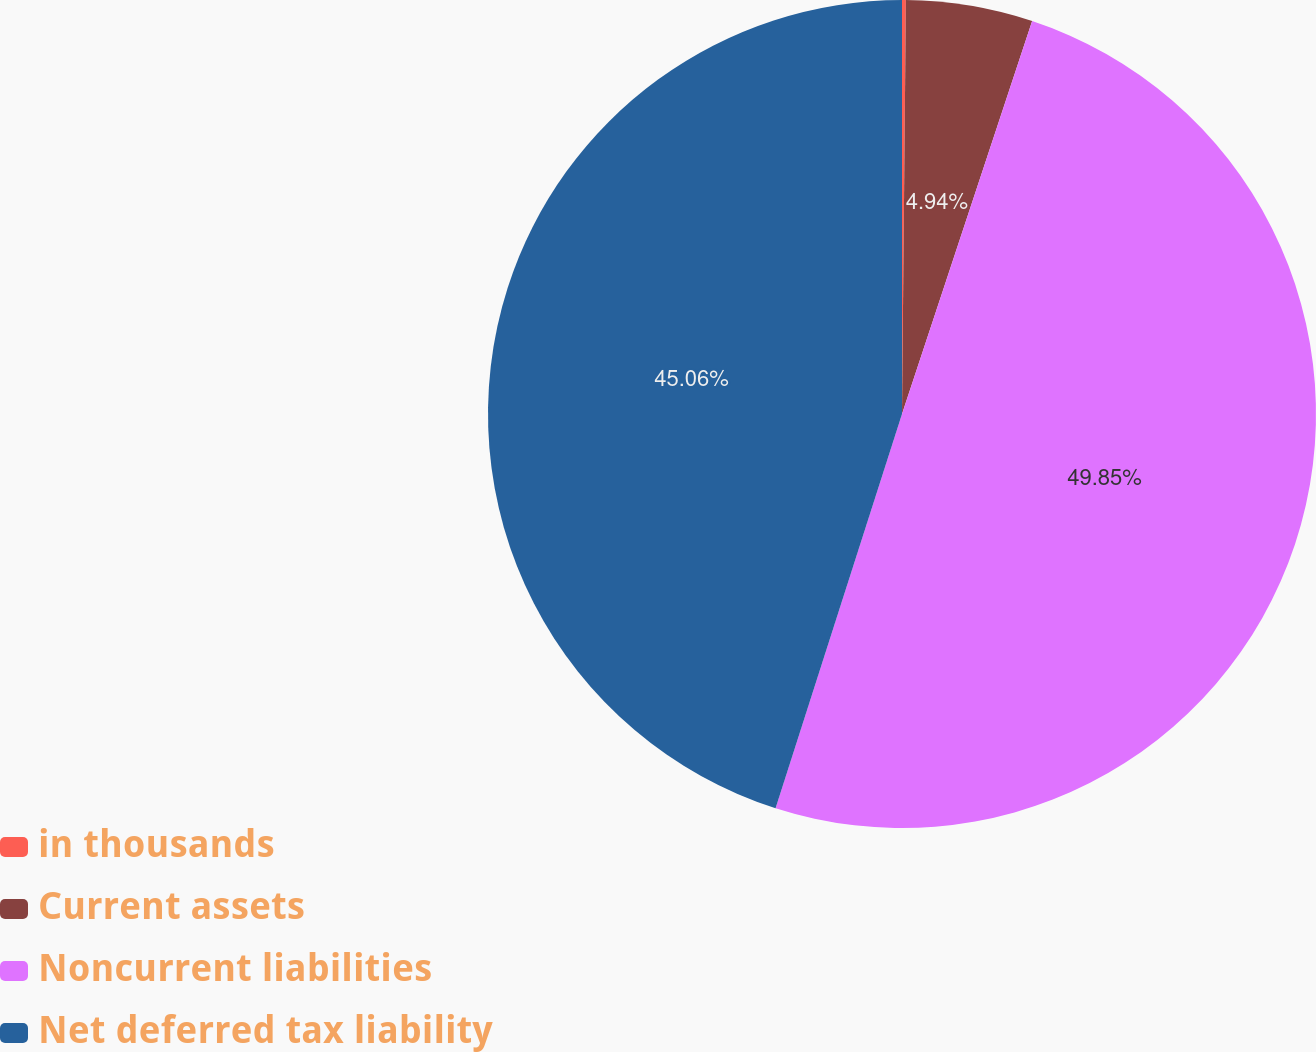Convert chart. <chart><loc_0><loc_0><loc_500><loc_500><pie_chart><fcel>in thousands<fcel>Current assets<fcel>Noncurrent liabilities<fcel>Net deferred tax liability<nl><fcel>0.15%<fcel>4.94%<fcel>49.85%<fcel>45.06%<nl></chart> 